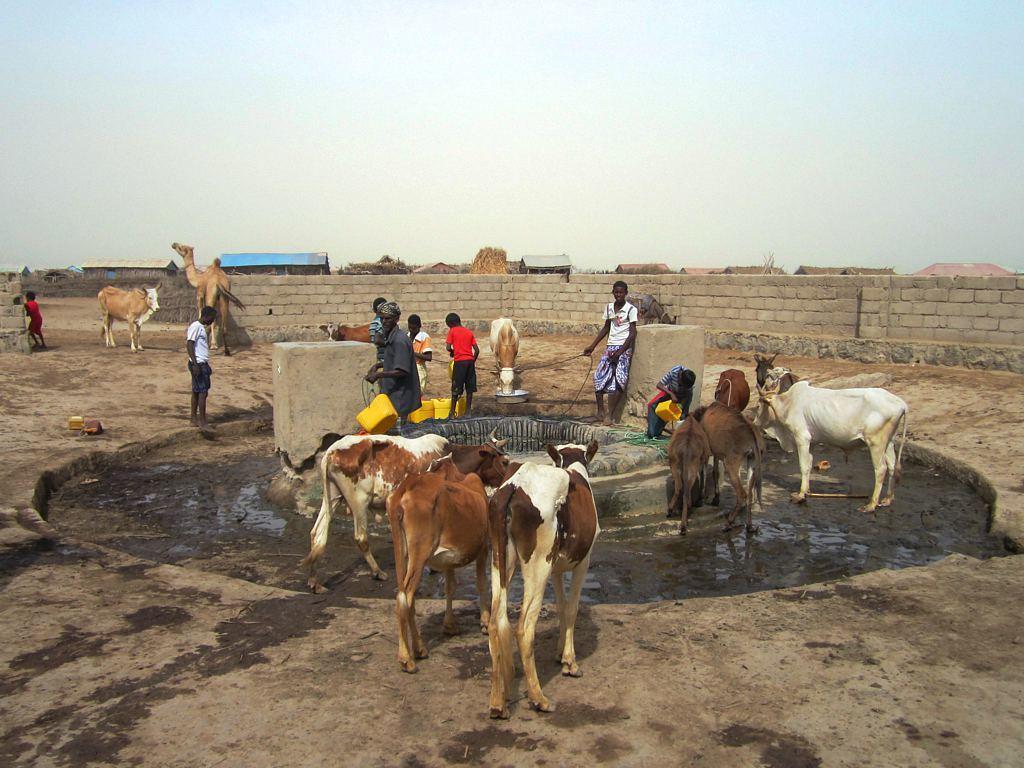Describe this image in one or two sentences. In this image there are cows and camels. At the center of the image there is a well and people are standing by holding the cans. In the background of the image there are buildings and sky. 